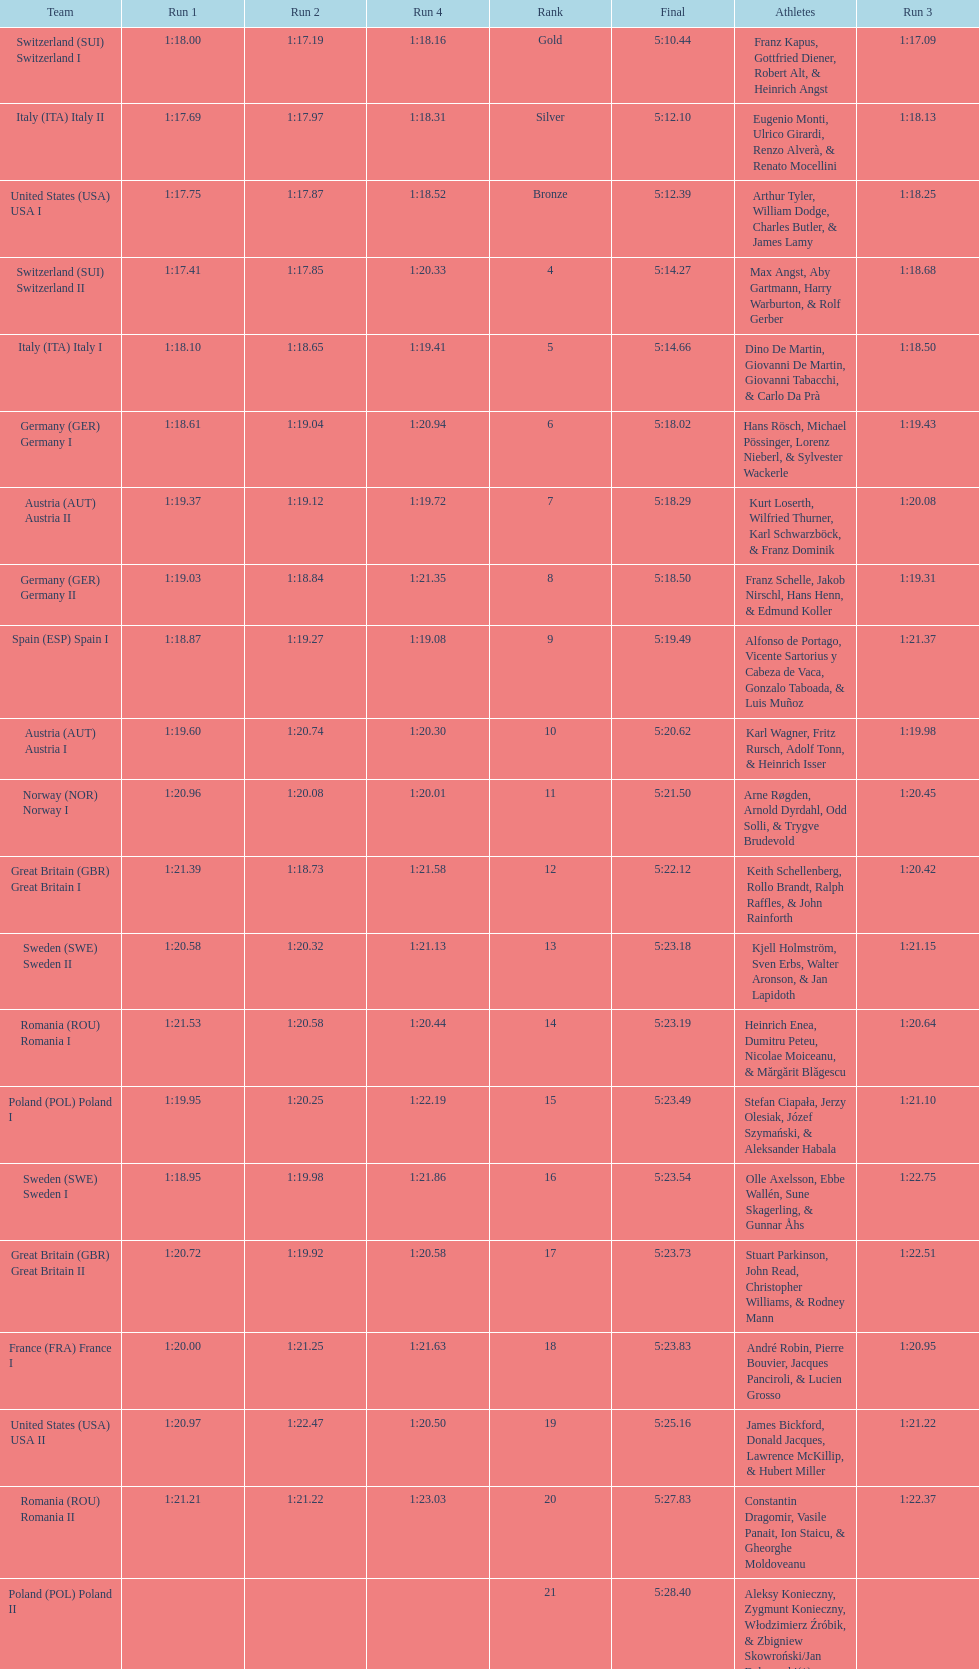Which team won the most runs? Switzerland. 